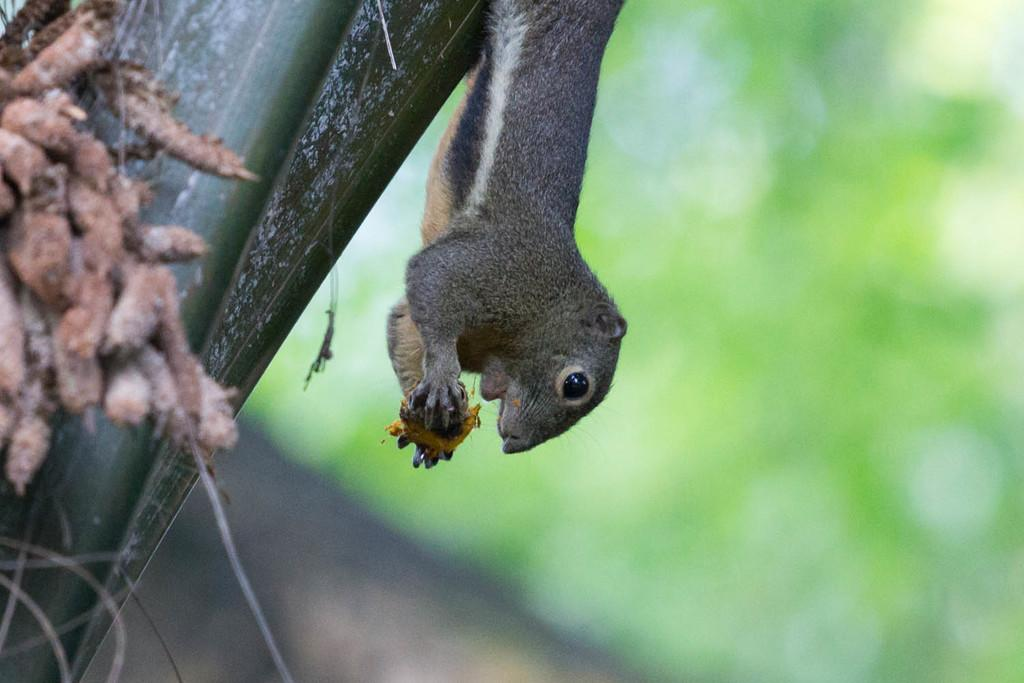What animal can be seen in the image? There is a squirrel in the image. Where is the squirrel located? The squirrel is on a tree. What is the distribution of the squirrel's afterthoughts in the image? There is no information about the squirrel's afterthoughts or their distribution in the image. 